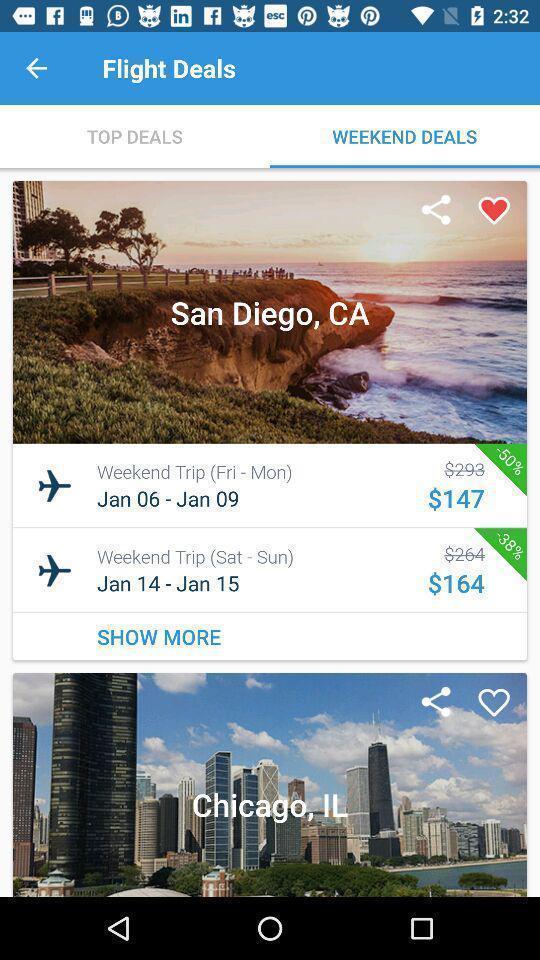Tell me about the visual elements in this screen capture. Weekend deals in the flight deals. 